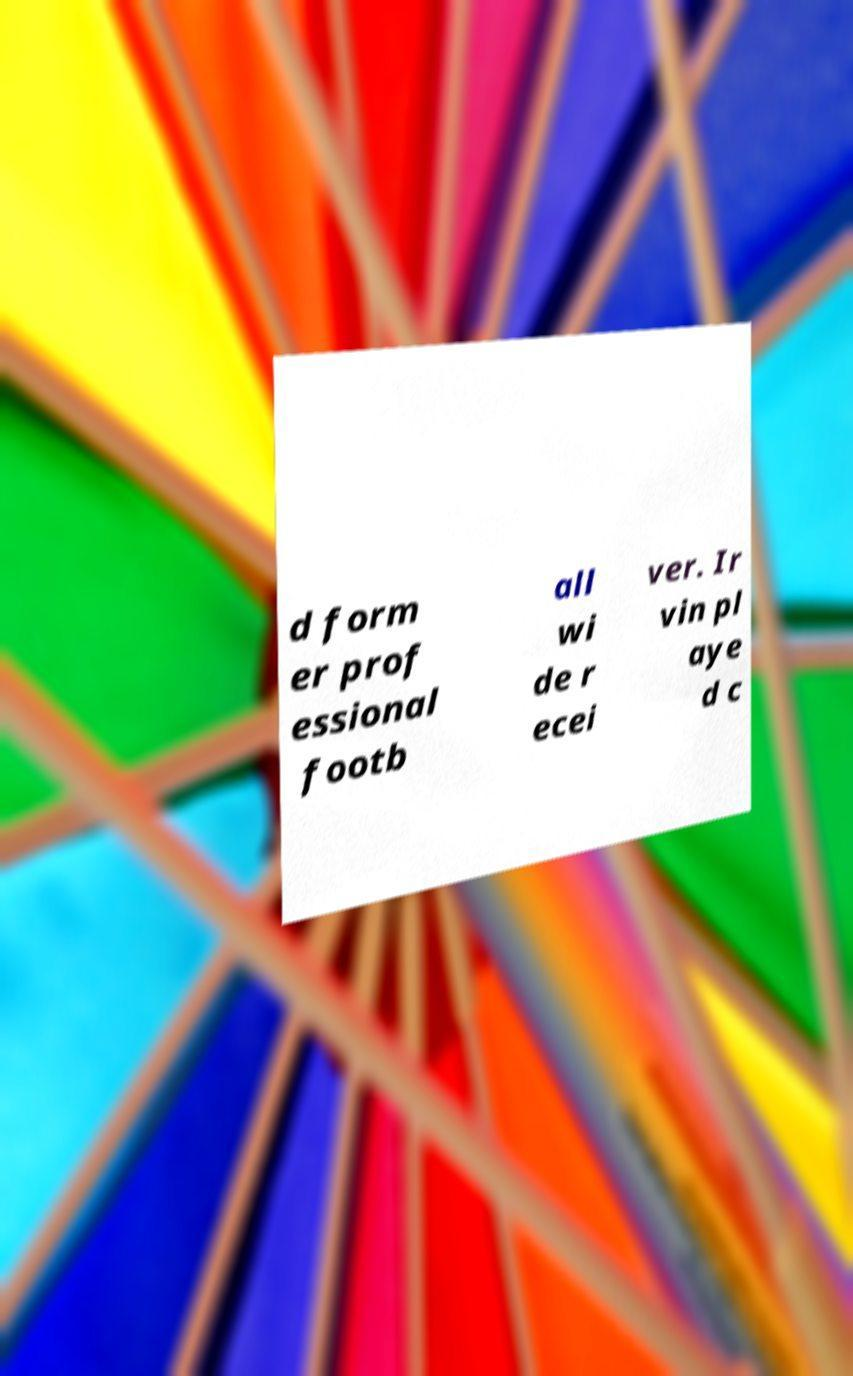Could you extract and type out the text from this image? d form er prof essional footb all wi de r ecei ver. Ir vin pl aye d c 